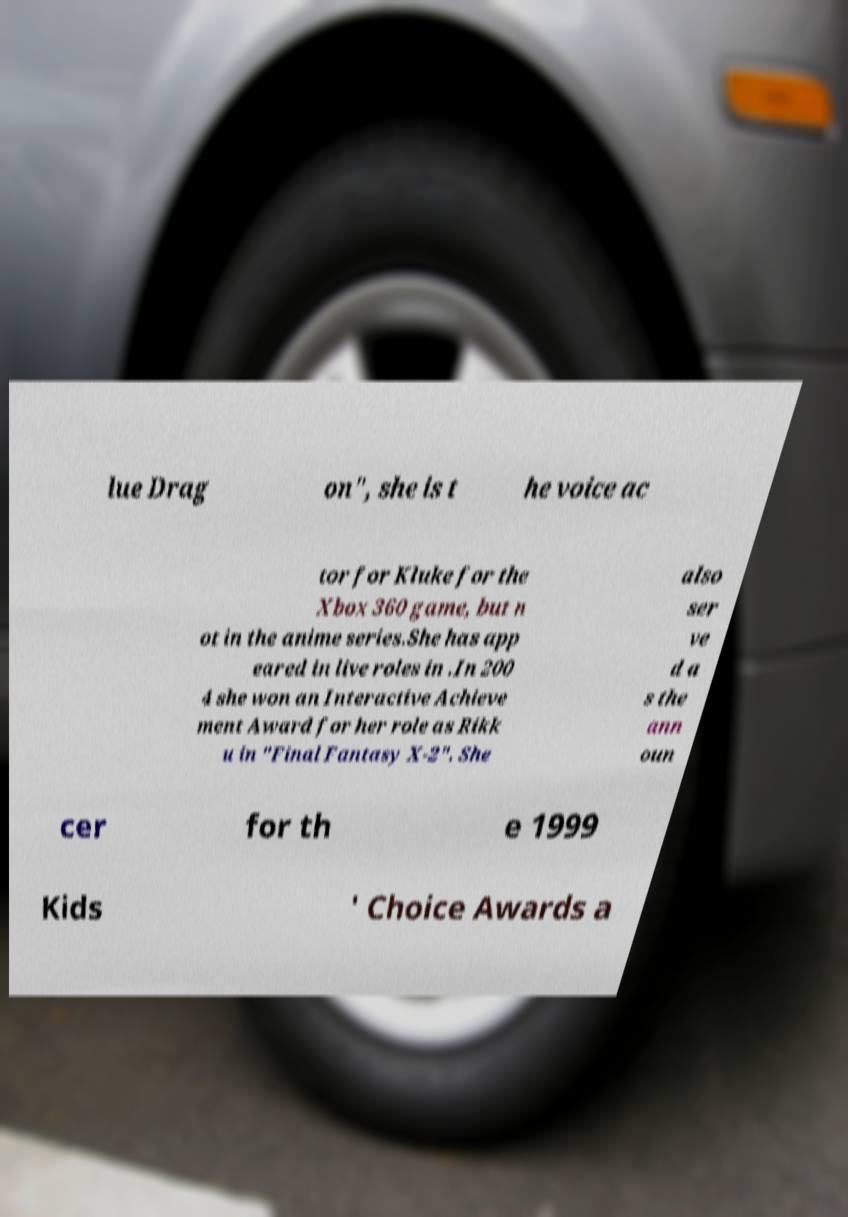Please identify and transcribe the text found in this image. lue Drag on", she is t he voice ac tor for Kluke for the Xbox 360 game, but n ot in the anime series.She has app eared in live roles in .In 200 4 she won an Interactive Achieve ment Award for her role as Rikk u in "Final Fantasy X-2". She also ser ve d a s the ann oun cer for th e 1999 Kids ' Choice Awards a 